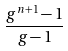Convert formula to latex. <formula><loc_0><loc_0><loc_500><loc_500>\frac { g ^ { n + 1 } - 1 } { g - 1 }</formula> 